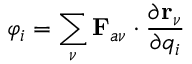Convert formula to latex. <formula><loc_0><loc_0><loc_500><loc_500>\varphi _ { i } = \sum _ { \nu } F _ { a \nu } \cdot \frac { \partial r _ { \nu } } { \partial q _ { i } }</formula> 